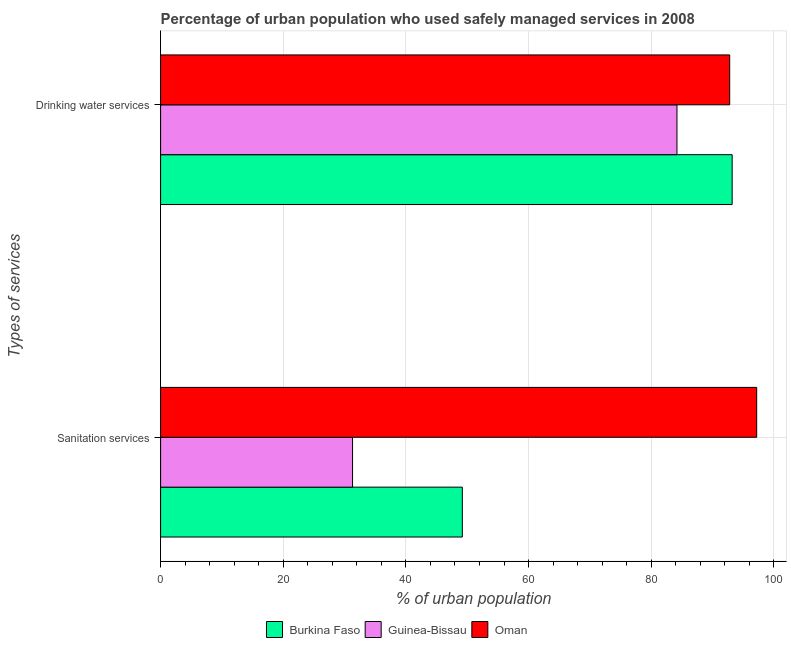How many groups of bars are there?
Make the answer very short. 2. Are the number of bars per tick equal to the number of legend labels?
Offer a very short reply. Yes. Are the number of bars on each tick of the Y-axis equal?
Offer a very short reply. Yes. How many bars are there on the 1st tick from the top?
Provide a succinct answer. 3. What is the label of the 1st group of bars from the top?
Keep it short and to the point. Drinking water services. What is the percentage of urban population who used sanitation services in Oman?
Keep it short and to the point. 97.2. Across all countries, what is the maximum percentage of urban population who used sanitation services?
Ensure brevity in your answer.  97.2. Across all countries, what is the minimum percentage of urban population who used drinking water services?
Give a very brief answer. 84.2. In which country was the percentage of urban population who used drinking water services maximum?
Your answer should be very brief. Burkina Faso. In which country was the percentage of urban population who used sanitation services minimum?
Offer a terse response. Guinea-Bissau. What is the total percentage of urban population who used sanitation services in the graph?
Your response must be concise. 177.7. What is the difference between the percentage of urban population who used sanitation services in Burkina Faso and that in Oman?
Make the answer very short. -48. What is the difference between the percentage of urban population who used drinking water services in Oman and the percentage of urban population who used sanitation services in Burkina Faso?
Give a very brief answer. 43.6. What is the average percentage of urban population who used sanitation services per country?
Make the answer very short. 59.23. What is the difference between the percentage of urban population who used drinking water services and percentage of urban population who used sanitation services in Guinea-Bissau?
Ensure brevity in your answer.  52.9. What is the ratio of the percentage of urban population who used drinking water services in Guinea-Bissau to that in Burkina Faso?
Provide a succinct answer. 0.9. Is the percentage of urban population who used sanitation services in Guinea-Bissau less than that in Oman?
Offer a very short reply. Yes. What does the 2nd bar from the top in Drinking water services represents?
Offer a very short reply. Guinea-Bissau. What does the 2nd bar from the bottom in Drinking water services represents?
Ensure brevity in your answer.  Guinea-Bissau. Are all the bars in the graph horizontal?
Offer a terse response. Yes. How many countries are there in the graph?
Your response must be concise. 3. What is the difference between two consecutive major ticks on the X-axis?
Provide a succinct answer. 20. Does the graph contain any zero values?
Keep it short and to the point. No. Does the graph contain grids?
Offer a very short reply. Yes. Where does the legend appear in the graph?
Offer a very short reply. Bottom center. What is the title of the graph?
Ensure brevity in your answer.  Percentage of urban population who used safely managed services in 2008. What is the label or title of the X-axis?
Your answer should be very brief. % of urban population. What is the label or title of the Y-axis?
Provide a succinct answer. Types of services. What is the % of urban population of Burkina Faso in Sanitation services?
Your answer should be compact. 49.2. What is the % of urban population of Guinea-Bissau in Sanitation services?
Offer a very short reply. 31.3. What is the % of urban population in Oman in Sanitation services?
Your answer should be compact. 97.2. What is the % of urban population of Burkina Faso in Drinking water services?
Offer a very short reply. 93.2. What is the % of urban population in Guinea-Bissau in Drinking water services?
Keep it short and to the point. 84.2. What is the % of urban population in Oman in Drinking water services?
Your response must be concise. 92.8. Across all Types of services, what is the maximum % of urban population in Burkina Faso?
Your answer should be compact. 93.2. Across all Types of services, what is the maximum % of urban population in Guinea-Bissau?
Ensure brevity in your answer.  84.2. Across all Types of services, what is the maximum % of urban population in Oman?
Your answer should be very brief. 97.2. Across all Types of services, what is the minimum % of urban population in Burkina Faso?
Your answer should be very brief. 49.2. Across all Types of services, what is the minimum % of urban population in Guinea-Bissau?
Give a very brief answer. 31.3. Across all Types of services, what is the minimum % of urban population in Oman?
Make the answer very short. 92.8. What is the total % of urban population in Burkina Faso in the graph?
Give a very brief answer. 142.4. What is the total % of urban population in Guinea-Bissau in the graph?
Your answer should be compact. 115.5. What is the total % of urban population in Oman in the graph?
Give a very brief answer. 190. What is the difference between the % of urban population in Burkina Faso in Sanitation services and that in Drinking water services?
Provide a short and direct response. -44. What is the difference between the % of urban population in Guinea-Bissau in Sanitation services and that in Drinking water services?
Give a very brief answer. -52.9. What is the difference between the % of urban population of Burkina Faso in Sanitation services and the % of urban population of Guinea-Bissau in Drinking water services?
Your answer should be very brief. -35. What is the difference between the % of urban population of Burkina Faso in Sanitation services and the % of urban population of Oman in Drinking water services?
Ensure brevity in your answer.  -43.6. What is the difference between the % of urban population in Guinea-Bissau in Sanitation services and the % of urban population in Oman in Drinking water services?
Offer a very short reply. -61.5. What is the average % of urban population in Burkina Faso per Types of services?
Your response must be concise. 71.2. What is the average % of urban population of Guinea-Bissau per Types of services?
Your answer should be very brief. 57.75. What is the average % of urban population in Oman per Types of services?
Your answer should be compact. 95. What is the difference between the % of urban population in Burkina Faso and % of urban population in Guinea-Bissau in Sanitation services?
Your answer should be very brief. 17.9. What is the difference between the % of urban population of Burkina Faso and % of urban population of Oman in Sanitation services?
Your response must be concise. -48. What is the difference between the % of urban population of Guinea-Bissau and % of urban population of Oman in Sanitation services?
Make the answer very short. -65.9. What is the difference between the % of urban population in Burkina Faso and % of urban population in Guinea-Bissau in Drinking water services?
Offer a very short reply. 9. What is the difference between the % of urban population in Burkina Faso and % of urban population in Oman in Drinking water services?
Make the answer very short. 0.4. What is the ratio of the % of urban population of Burkina Faso in Sanitation services to that in Drinking water services?
Ensure brevity in your answer.  0.53. What is the ratio of the % of urban population of Guinea-Bissau in Sanitation services to that in Drinking water services?
Your answer should be very brief. 0.37. What is the ratio of the % of urban population in Oman in Sanitation services to that in Drinking water services?
Ensure brevity in your answer.  1.05. What is the difference between the highest and the second highest % of urban population of Burkina Faso?
Ensure brevity in your answer.  44. What is the difference between the highest and the second highest % of urban population of Guinea-Bissau?
Your response must be concise. 52.9. What is the difference between the highest and the lowest % of urban population of Guinea-Bissau?
Ensure brevity in your answer.  52.9. 